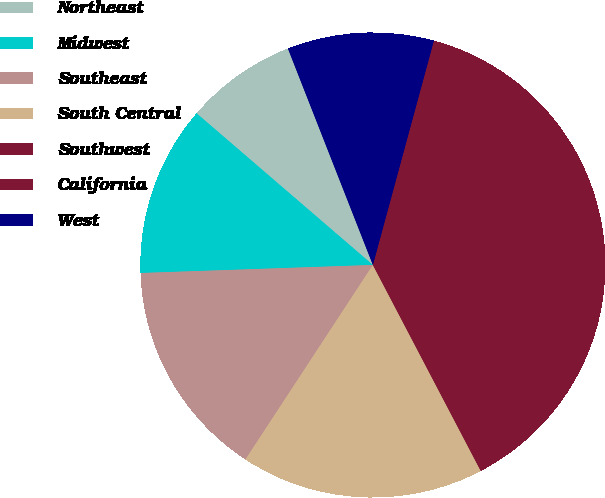Convert chart. <chart><loc_0><loc_0><loc_500><loc_500><pie_chart><fcel>Northeast<fcel>Midwest<fcel>Southeast<fcel>South Central<fcel>Southwest<fcel>California<fcel>West<nl><fcel>7.74%<fcel>11.86%<fcel>15.22%<fcel>16.91%<fcel>13.54%<fcel>24.56%<fcel>10.18%<nl></chart> 